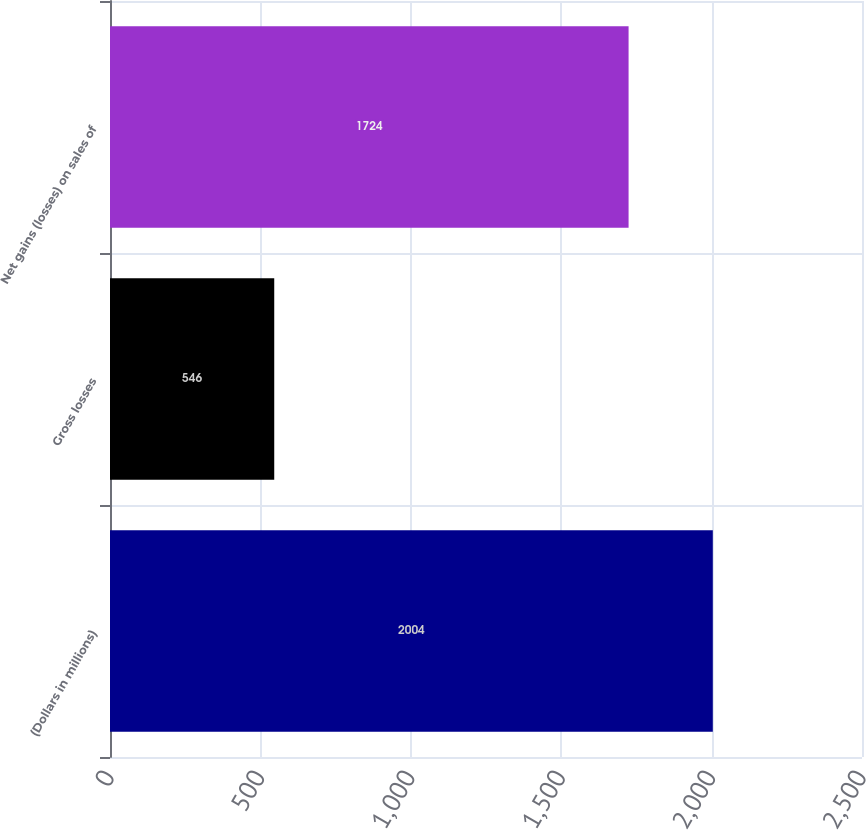Convert chart to OTSL. <chart><loc_0><loc_0><loc_500><loc_500><bar_chart><fcel>(Dollars in millions)<fcel>Gross losses<fcel>Net gains (losses) on sales of<nl><fcel>2004<fcel>546<fcel>1724<nl></chart> 